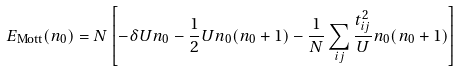<formula> <loc_0><loc_0><loc_500><loc_500>E _ { \text {Mott} } ( n _ { 0 } ) = N \left [ - \delta U n _ { 0 } - \frac { 1 } { 2 } U n _ { 0 } ( n _ { 0 } + 1 ) - \frac { 1 } { N } \sum _ { i j } \frac { t _ { i j } ^ { 2 } } { U } n _ { 0 } ( n _ { 0 } + 1 ) \right ]</formula> 